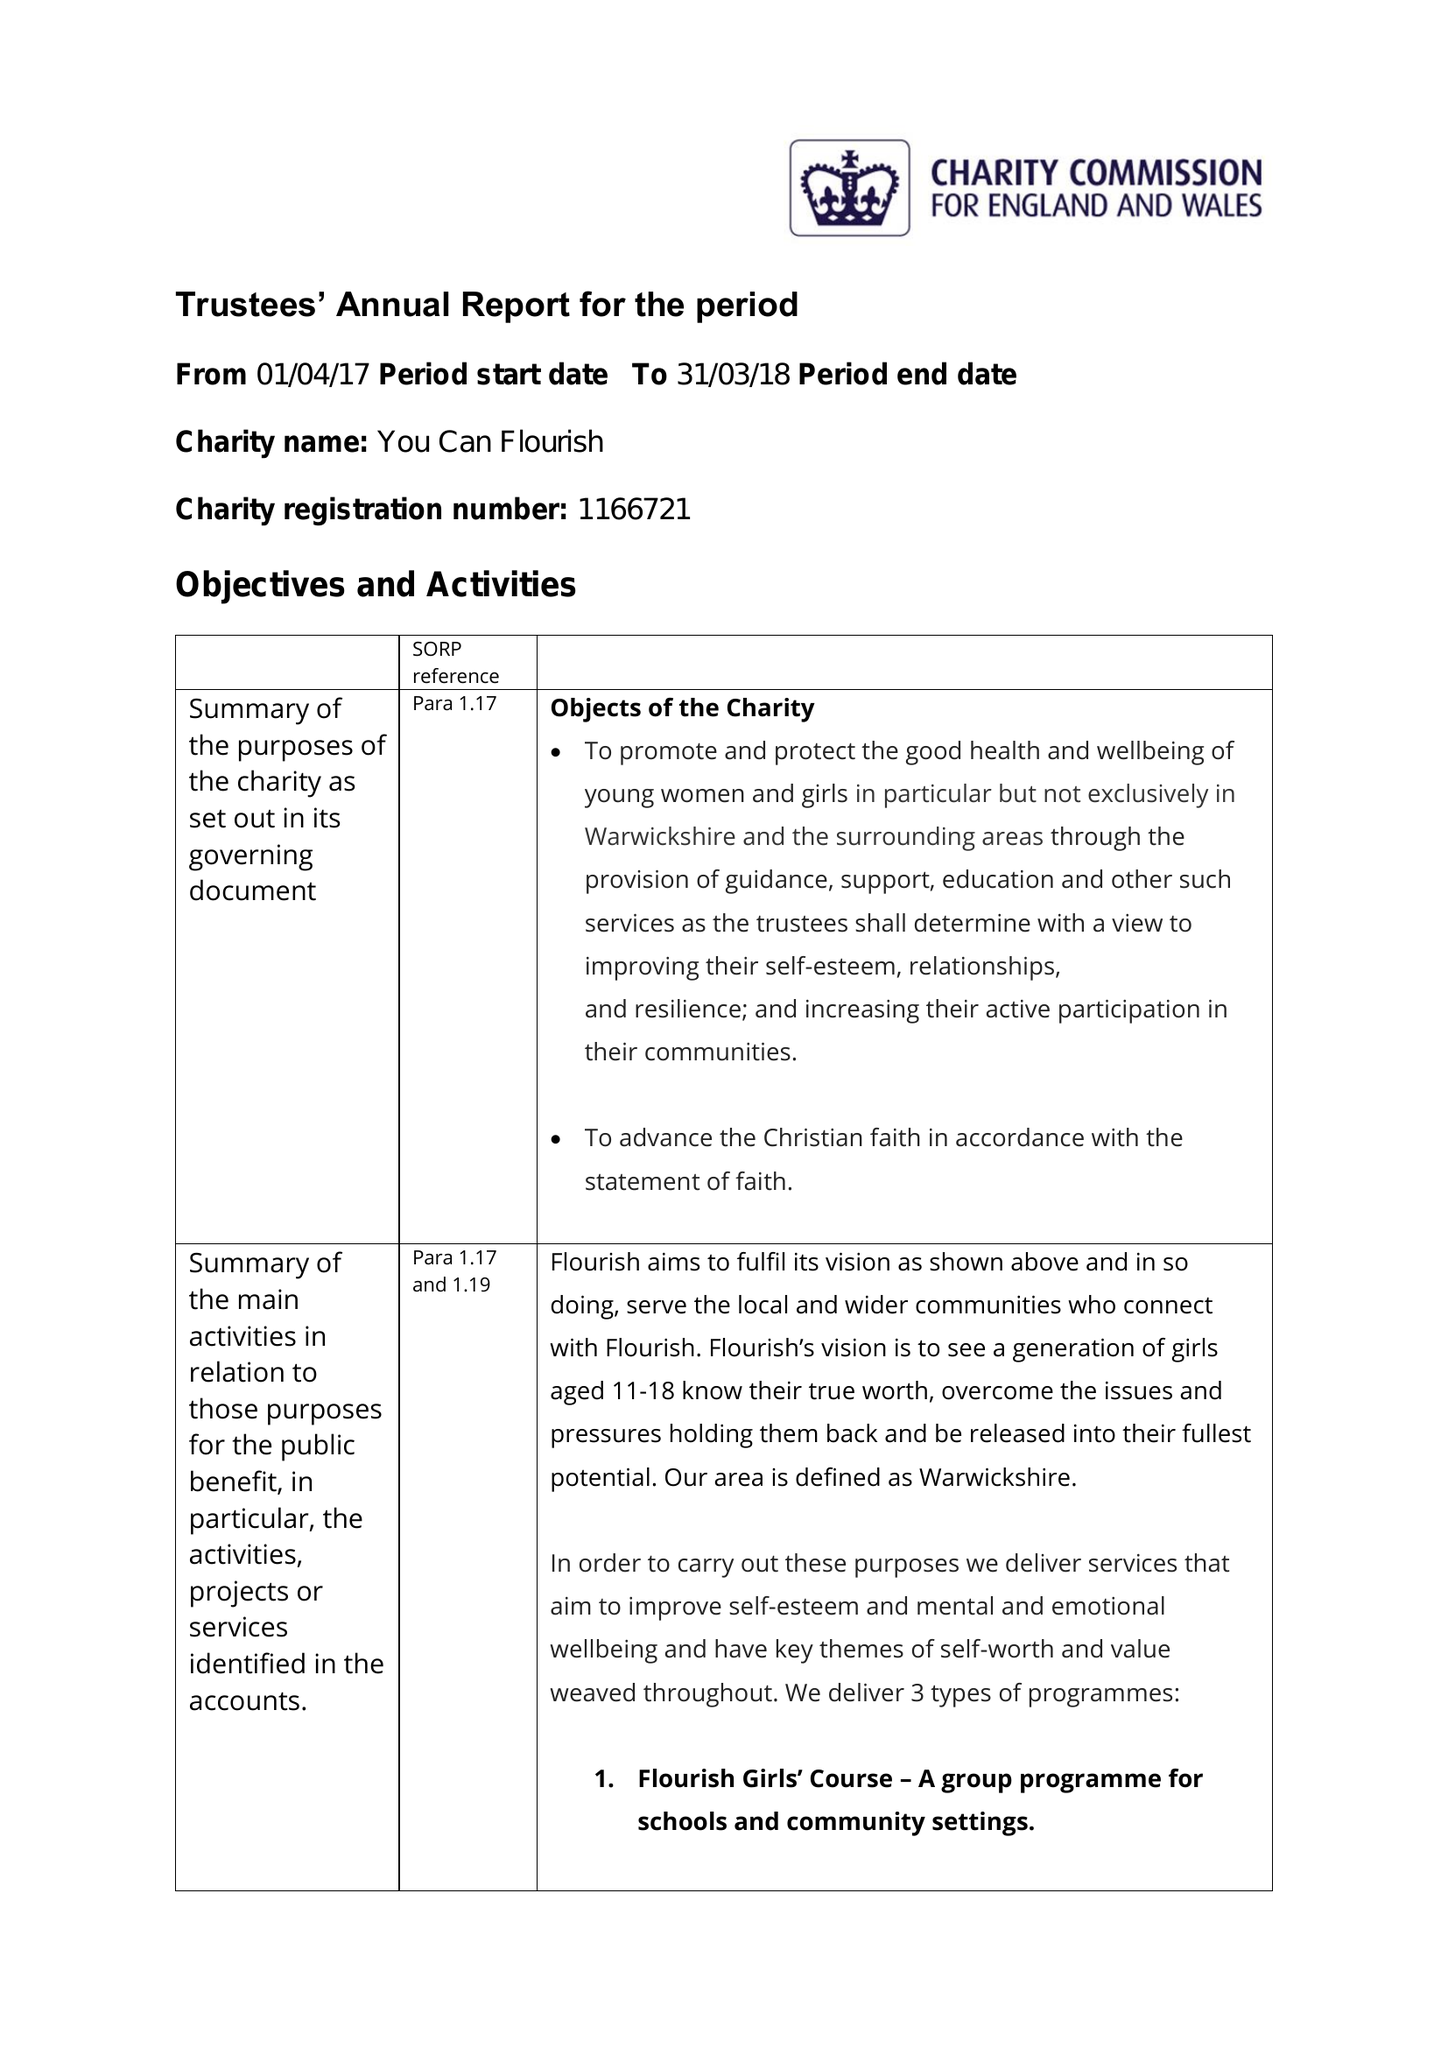What is the value for the spending_annually_in_british_pounds?
Answer the question using a single word or phrase. 12903.00 